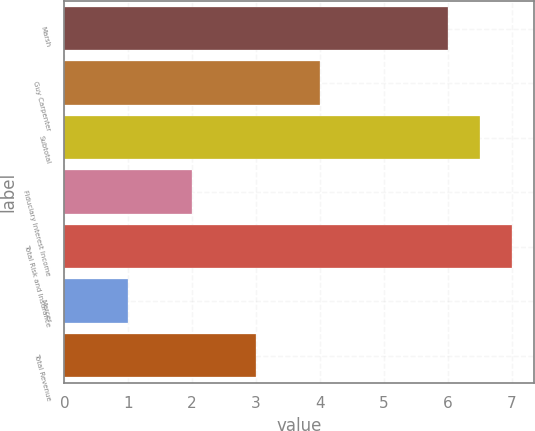Convert chart to OTSL. <chart><loc_0><loc_0><loc_500><loc_500><bar_chart><fcel>Marsh<fcel>Guy Carpenter<fcel>Subtotal<fcel>Fiduciary Interest Income<fcel>Total Risk and Insurance<fcel>Mercer<fcel>Total Revenue<nl><fcel>6<fcel>4<fcel>6.5<fcel>2<fcel>7<fcel>1<fcel>3<nl></chart> 